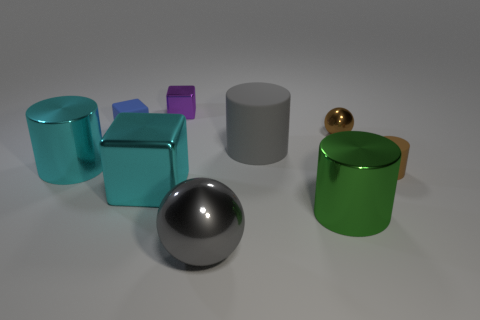Which object stands out the most to you? The sphere stands out due to its distinct shape and glossy reflective surface. Its curvature and shine draw attention, making it a focal point among the other objects which are primarily various types of cylinders and a cube. 